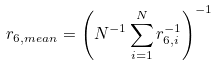Convert formula to latex. <formula><loc_0><loc_0><loc_500><loc_500>r _ { 6 , m e a n } = \left ( N ^ { - 1 } \sum _ { i = 1 } ^ { N } r _ { 6 , i } ^ { - 1 } \right ) ^ { - 1 }</formula> 